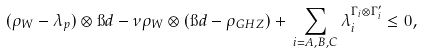<formula> <loc_0><loc_0><loc_500><loc_500>( \rho _ { W } - \lambda _ { p } ) \otimes \i d - \nu \rho _ { W } \otimes ( \i d - \rho _ { G H Z } ) + \, \sum _ { i = A , B , C } \lambda _ { i } ^ { \Gamma _ { i } \otimes \Gamma ^ { \prime } _ { i } } \leq 0 ,</formula> 